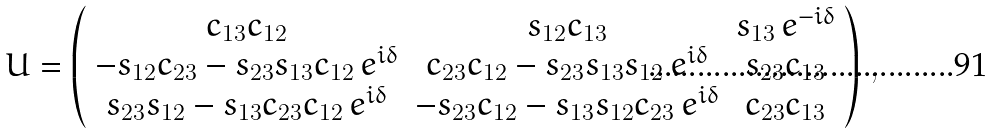Convert formula to latex. <formula><loc_0><loc_0><loc_500><loc_500>U = \left ( \begin{array} { c c c } c _ { 1 3 } c _ { 1 2 } & s _ { 1 2 } c _ { 1 3 } & s _ { 1 3 } \, { e } ^ { - i \delta } \\ - s _ { 1 2 } c _ { 2 3 } - s _ { 2 3 } s _ { 1 3 } c _ { 1 2 } \, { e } ^ { i \delta } & c _ { 2 3 } c _ { 1 2 } - s _ { 2 3 } s _ { 1 3 } s _ { 1 2 } \, { e } ^ { i \delta } & s _ { 2 3 } c _ { 1 3 } \\ s _ { 2 3 } s _ { 1 2 } - s _ { 1 3 } c _ { 2 3 } c _ { 1 2 } \, { e } ^ { i \delta } & - s _ { 2 3 } c _ { 1 2 } - s _ { 1 3 } s _ { 1 2 } c _ { 2 3 } \, { e } ^ { i \delta } & c _ { 2 3 } c _ { 1 3 } \end{array} \right ) \, ,</formula> 